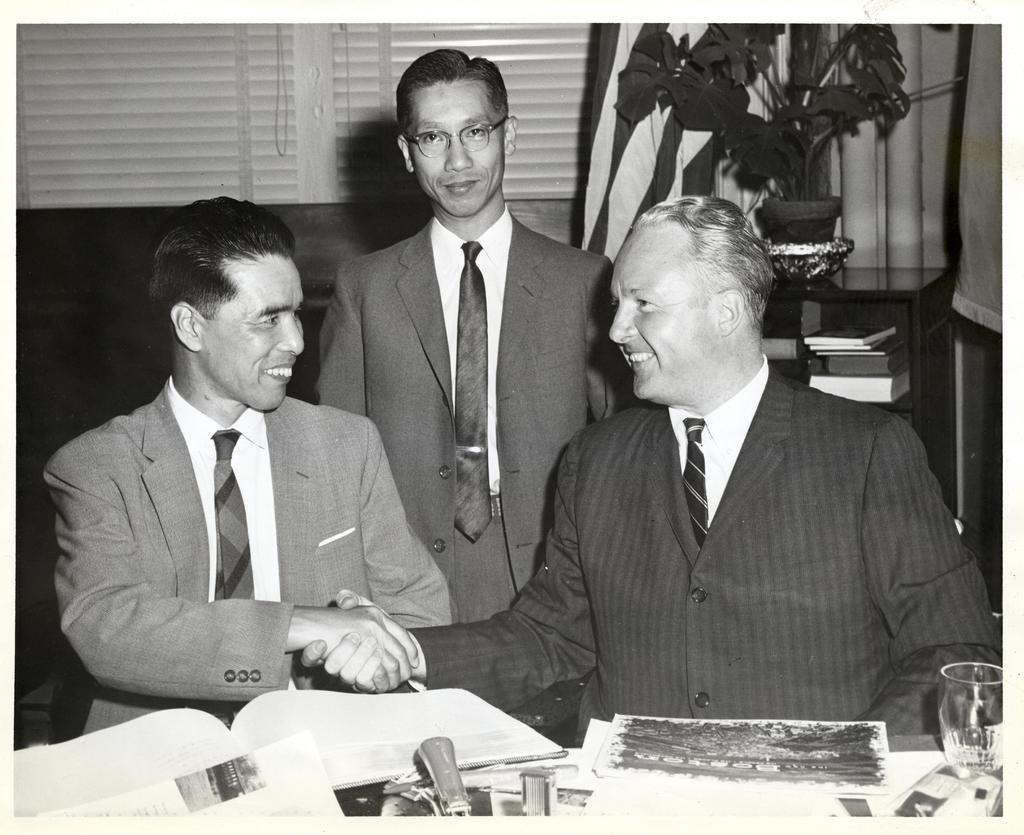How many people are in the image? There are three people in the image. What is the facial expression of the people in the image? The people are smiling in the image. What type of clothing are the people wearing? The people are wearing ties in the image. What can be seen on the table in the image? There is a glass, books, papers, and a houseplant on the table in the image. What is the background of the image? There is a flag and a curtain in the image. Can you describe any other objects in the image? There are some objects in the image, but their specific details are not mentioned in the provided facts. What type of skin condition can be seen on the people in the image? There is no mention of any skin condition in the image, and the people's skin is not visible in the provided facts. What is the caption for the image? There is no caption provided for the image in the given facts. 